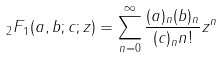<formula> <loc_0><loc_0><loc_500><loc_500>{ } _ { 2 } F _ { 1 } ( a , b ; c ; z ) = \sum _ { n = 0 } ^ { \infty } \frac { ( a ) _ { n } ( b ) _ { n } } { ( c ) _ { n } n ! } z ^ { n }</formula> 